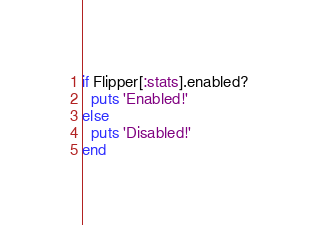Convert code to text. <code><loc_0><loc_0><loc_500><loc_500><_Ruby_>if Flipper[:stats].enabled?
  puts 'Enabled!'
else
  puts 'Disabled!'
end
</code> 